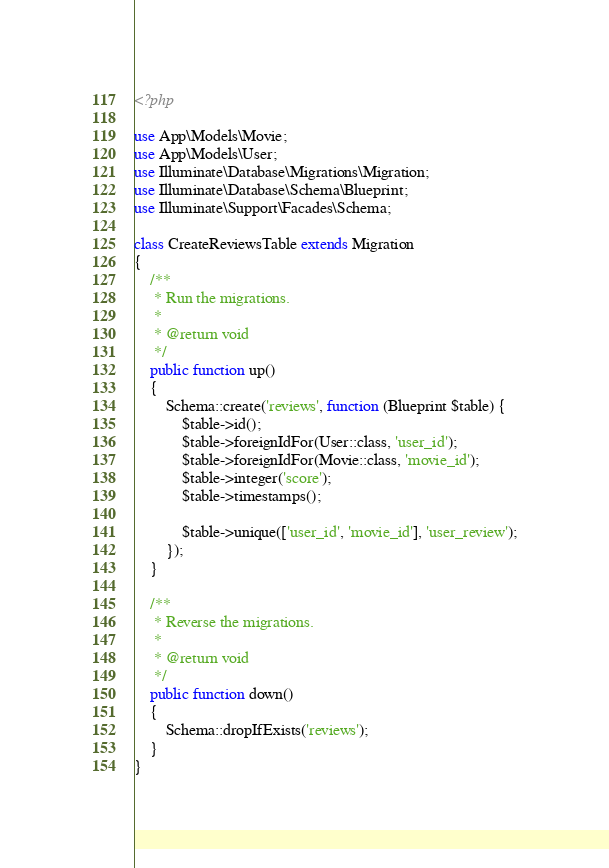Convert code to text. <code><loc_0><loc_0><loc_500><loc_500><_PHP_><?php

use App\Models\Movie;
use App\Models\User;
use Illuminate\Database\Migrations\Migration;
use Illuminate\Database\Schema\Blueprint;
use Illuminate\Support\Facades\Schema;

class CreateReviewsTable extends Migration
{
    /**
     * Run the migrations.
     *
     * @return void
     */
    public function up()
    {
        Schema::create('reviews', function (Blueprint $table) {
            $table->id();
            $table->foreignIdFor(User::class, 'user_id');
            $table->foreignIdFor(Movie::class, 'movie_id');
            $table->integer('score');
            $table->timestamps();

            $table->unique(['user_id', 'movie_id'], 'user_review');
        });
    }

    /**
     * Reverse the migrations.
     *
     * @return void
     */
    public function down()
    {
        Schema::dropIfExists('reviews');
    }
}
</code> 